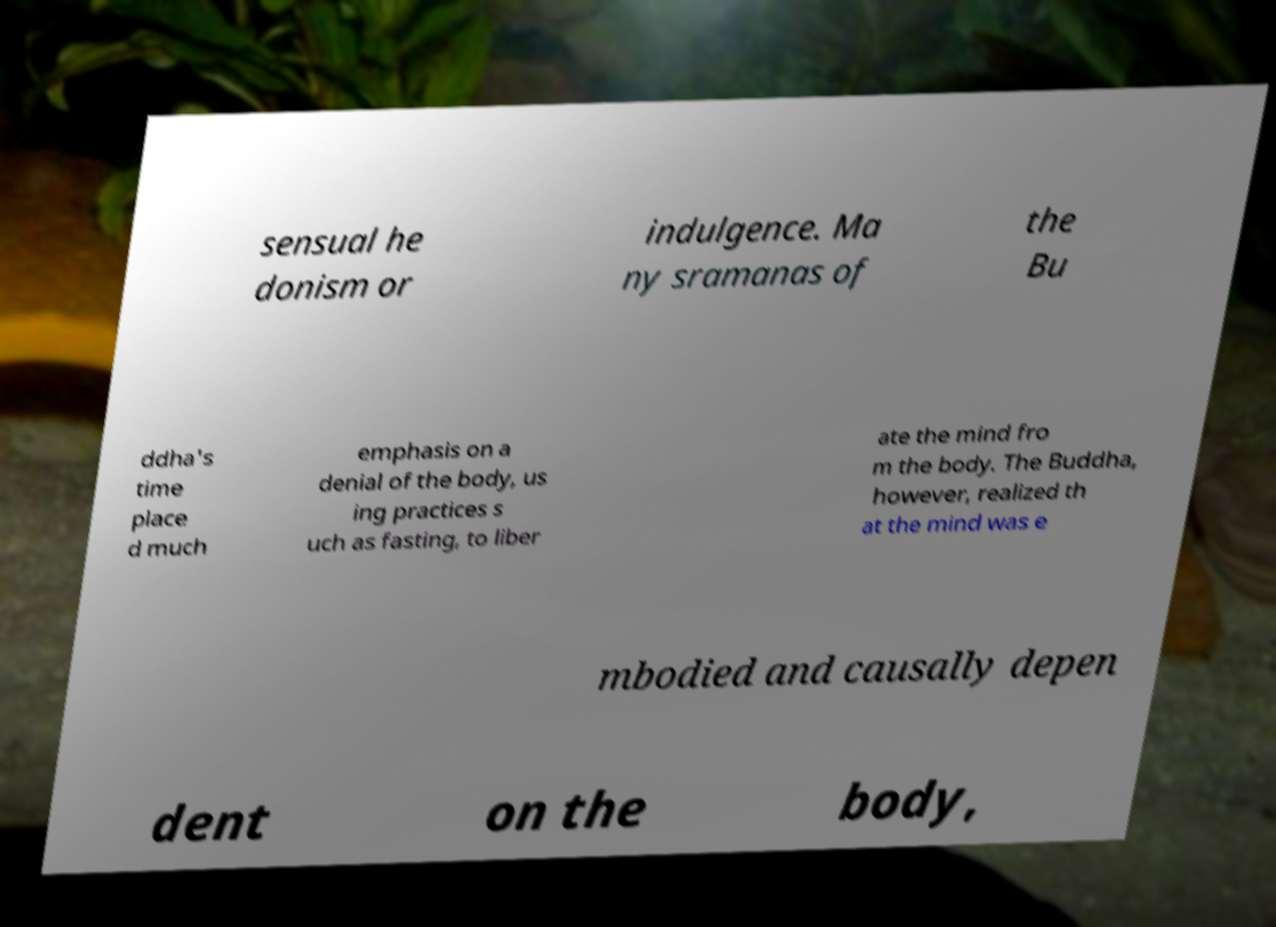Please identify and transcribe the text found in this image. sensual he donism or indulgence. Ma ny sramanas of the Bu ddha's time place d much emphasis on a denial of the body, us ing practices s uch as fasting, to liber ate the mind fro m the body. The Buddha, however, realized th at the mind was e mbodied and causally depen dent on the body, 